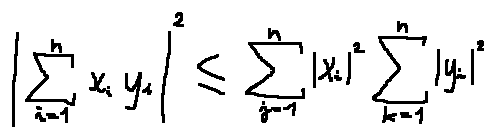<formula> <loc_0><loc_0><loc_500><loc_500>| \sum \lim i t s _ { i = 1 } ^ { n } x _ { i } y _ { i } | ^ { 2 } \leq \sum \lim i t s _ { j = 1 } ^ { n } | x _ { i } | ^ { 2 } \sum \lim i t s _ { k = 1 } ^ { n } | y _ { i } | ^ { 2 }</formula> 